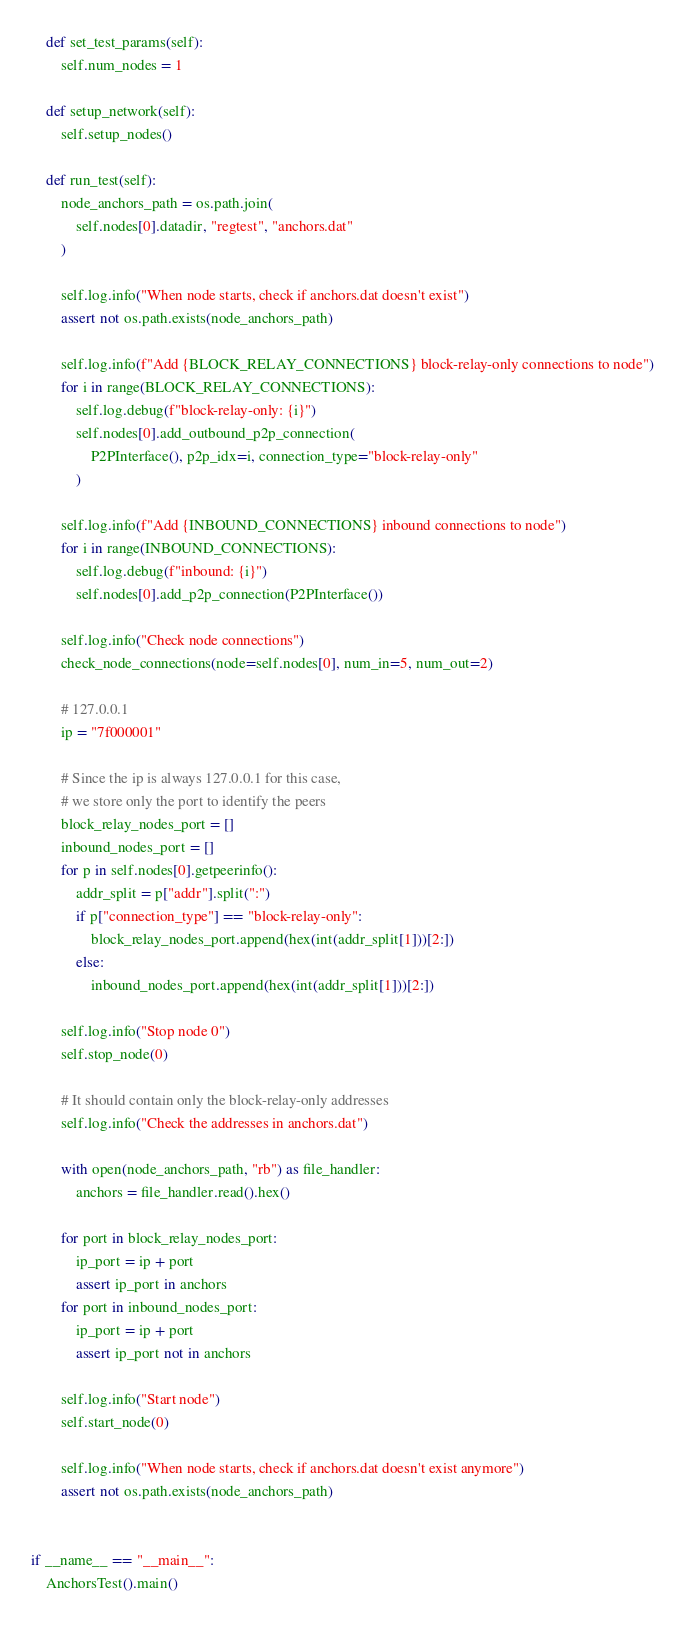Convert code to text. <code><loc_0><loc_0><loc_500><loc_500><_Python_>    def set_test_params(self):
        self.num_nodes = 1

    def setup_network(self):
        self.setup_nodes()

    def run_test(self):
        node_anchors_path = os.path.join(
            self.nodes[0].datadir, "regtest", "anchors.dat"
        )

        self.log.info("When node starts, check if anchors.dat doesn't exist")
        assert not os.path.exists(node_anchors_path)

        self.log.info(f"Add {BLOCK_RELAY_CONNECTIONS} block-relay-only connections to node")
        for i in range(BLOCK_RELAY_CONNECTIONS):
            self.log.debug(f"block-relay-only: {i}")
            self.nodes[0].add_outbound_p2p_connection(
                P2PInterface(), p2p_idx=i, connection_type="block-relay-only"
            )

        self.log.info(f"Add {INBOUND_CONNECTIONS} inbound connections to node")
        for i in range(INBOUND_CONNECTIONS):
            self.log.debug(f"inbound: {i}")
            self.nodes[0].add_p2p_connection(P2PInterface())

        self.log.info("Check node connections")
        check_node_connections(node=self.nodes[0], num_in=5, num_out=2)

        # 127.0.0.1
        ip = "7f000001"

        # Since the ip is always 127.0.0.1 for this case,
        # we store only the port to identify the peers
        block_relay_nodes_port = []
        inbound_nodes_port = []
        for p in self.nodes[0].getpeerinfo():
            addr_split = p["addr"].split(":")
            if p["connection_type"] == "block-relay-only":
                block_relay_nodes_port.append(hex(int(addr_split[1]))[2:])
            else:
                inbound_nodes_port.append(hex(int(addr_split[1]))[2:])

        self.log.info("Stop node 0")
        self.stop_node(0)

        # It should contain only the block-relay-only addresses
        self.log.info("Check the addresses in anchors.dat")

        with open(node_anchors_path, "rb") as file_handler:
            anchors = file_handler.read().hex()

        for port in block_relay_nodes_port:
            ip_port = ip + port
            assert ip_port in anchors
        for port in inbound_nodes_port:
            ip_port = ip + port
            assert ip_port not in anchors

        self.log.info("Start node")
        self.start_node(0)

        self.log.info("When node starts, check if anchors.dat doesn't exist anymore")
        assert not os.path.exists(node_anchors_path)


if __name__ == "__main__":
    AnchorsTest().main()
</code> 